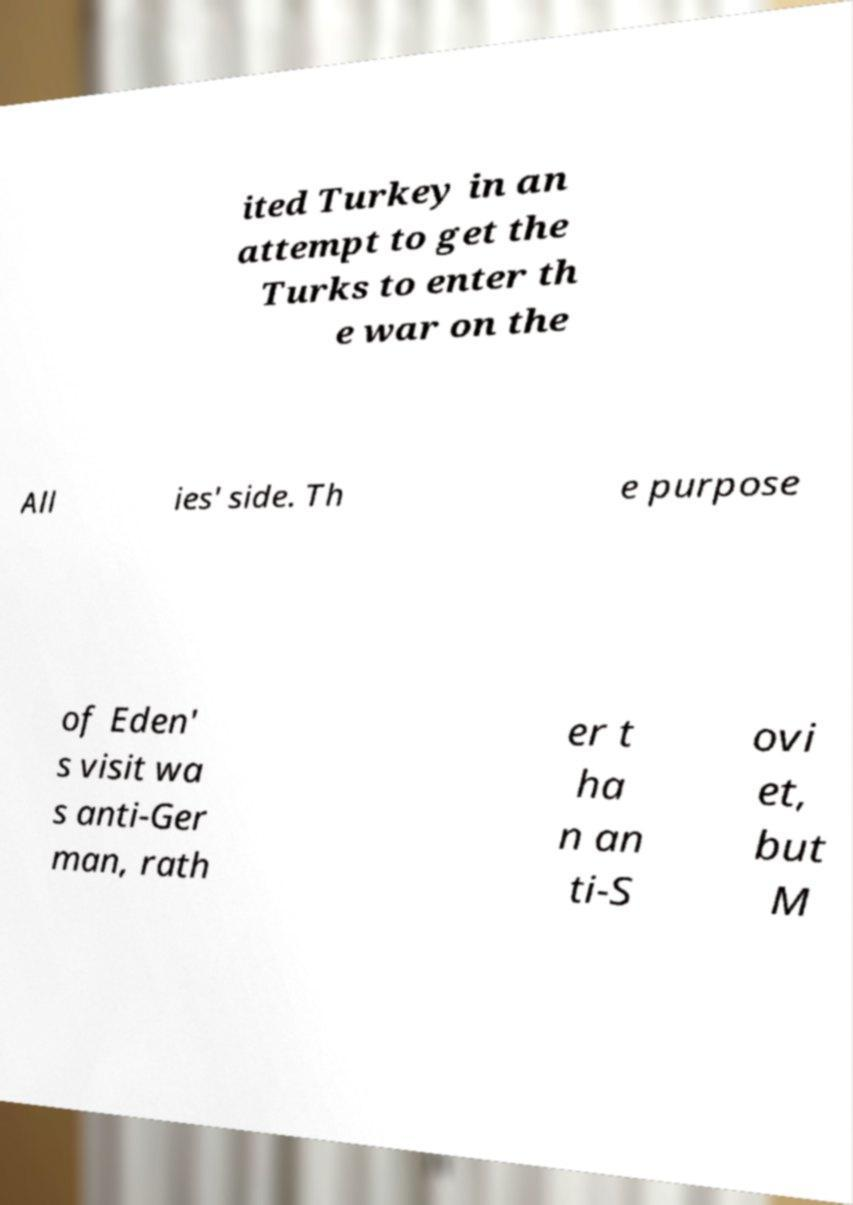Can you read and provide the text displayed in the image?This photo seems to have some interesting text. Can you extract and type it out for me? ited Turkey in an attempt to get the Turks to enter th e war on the All ies' side. Th e purpose of Eden' s visit wa s anti-Ger man, rath er t ha n an ti-S ovi et, but M 